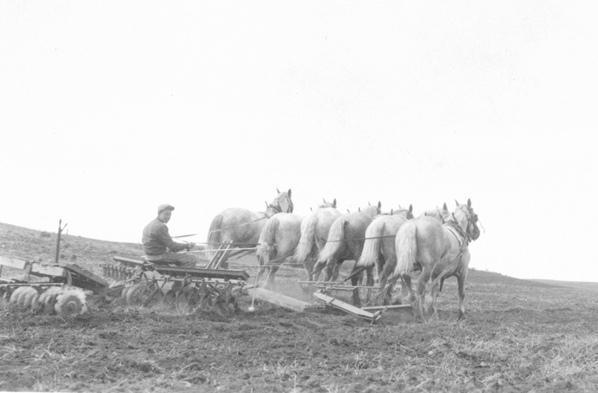How many horses are shown?
Give a very brief answer. 6. How many horses are there?
Give a very brief answer. 5. 